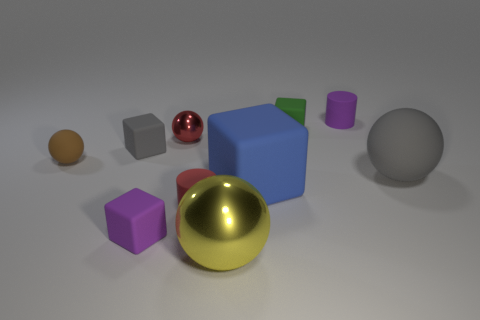What number of metallic objects are cylinders or big gray things?
Provide a short and direct response. 0. There is a tiny cylinder behind the blue matte block; how many things are to the left of it?
Ensure brevity in your answer.  8. How many objects are red matte things or things that are to the right of the tiny red shiny object?
Provide a short and direct response. 6. Is there a green block that has the same material as the blue thing?
Your answer should be very brief. Yes. What number of small objects are both on the left side of the purple rubber block and behind the brown rubber object?
Ensure brevity in your answer.  1. What material is the gray object on the right side of the purple cylinder?
Make the answer very short. Rubber. There is a blue block that is made of the same material as the big gray sphere; what size is it?
Offer a terse response. Large. There is a gray cube; are there any big gray things behind it?
Ensure brevity in your answer.  No. What is the size of the blue rubber thing that is the same shape as the tiny gray thing?
Keep it short and to the point. Large. There is a small shiny thing; does it have the same color as the rubber cylinder in front of the tiny brown ball?
Provide a short and direct response. Yes. 